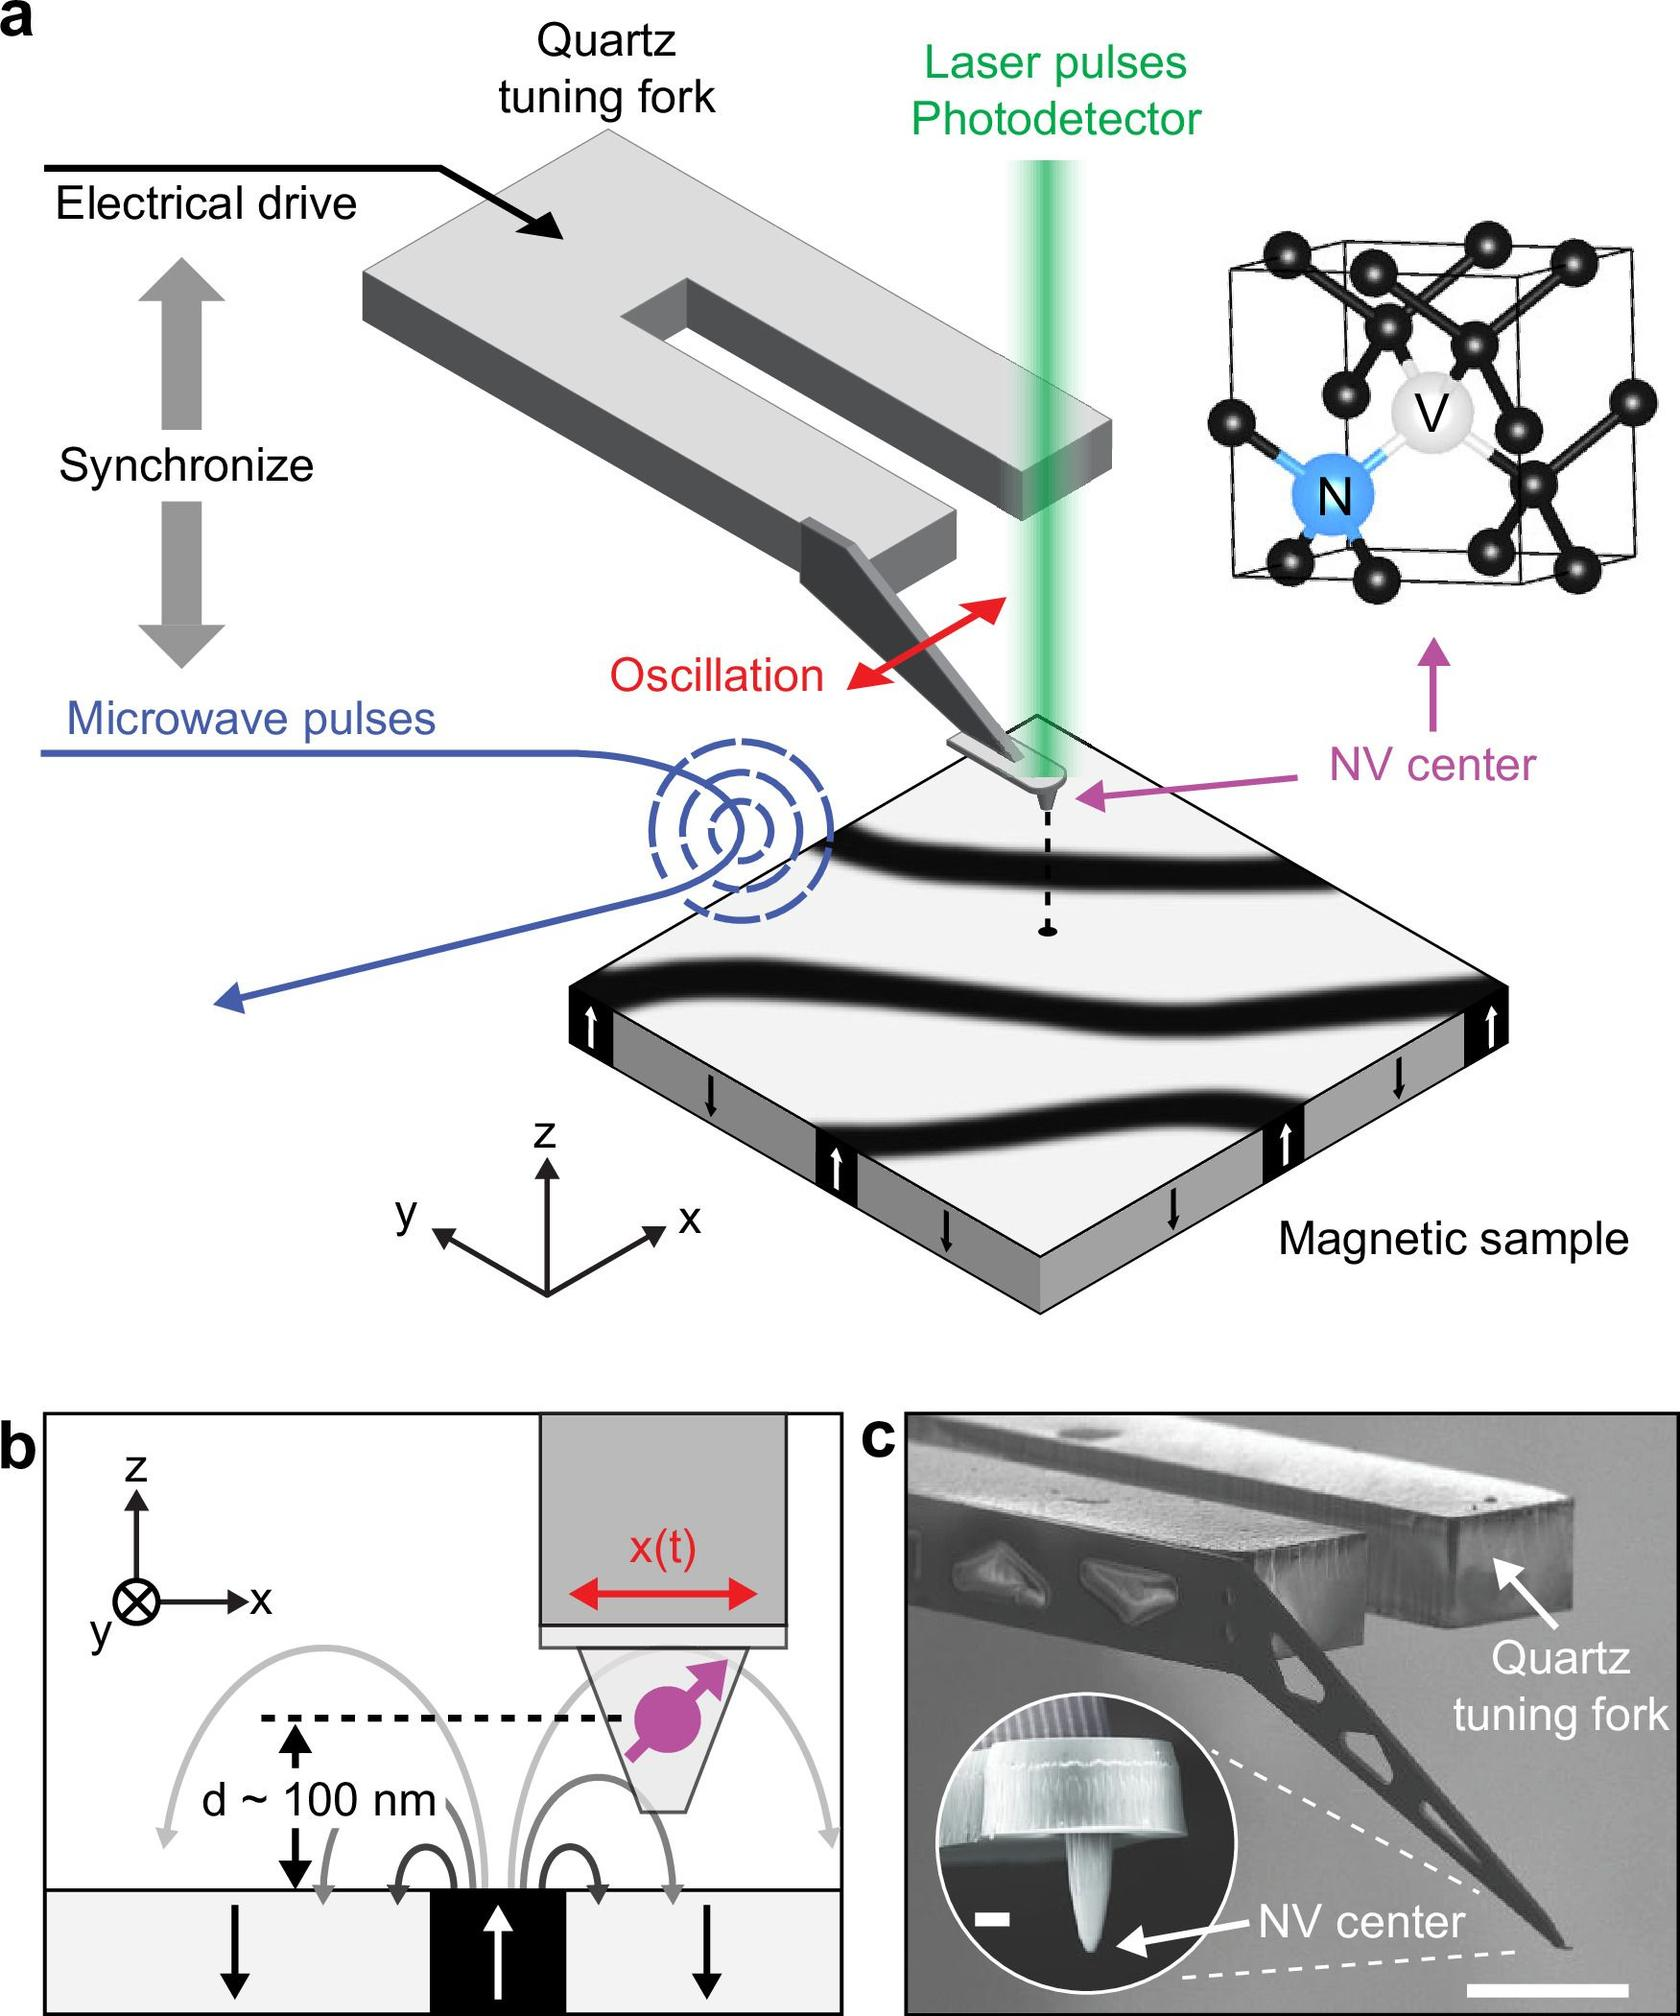What is the primary purpose of the quartz tuning fork in this experimental setup? In this experimental setup, the quartz tuning fork is crucial for providing mechanical oscillation that is synchronized with microwave pulses. This synchronization facilitates precise control and manipulation of the setup, allowing for accurate measurements and analyses, especially concerning the NV center's responses to changing magnetic fields. 